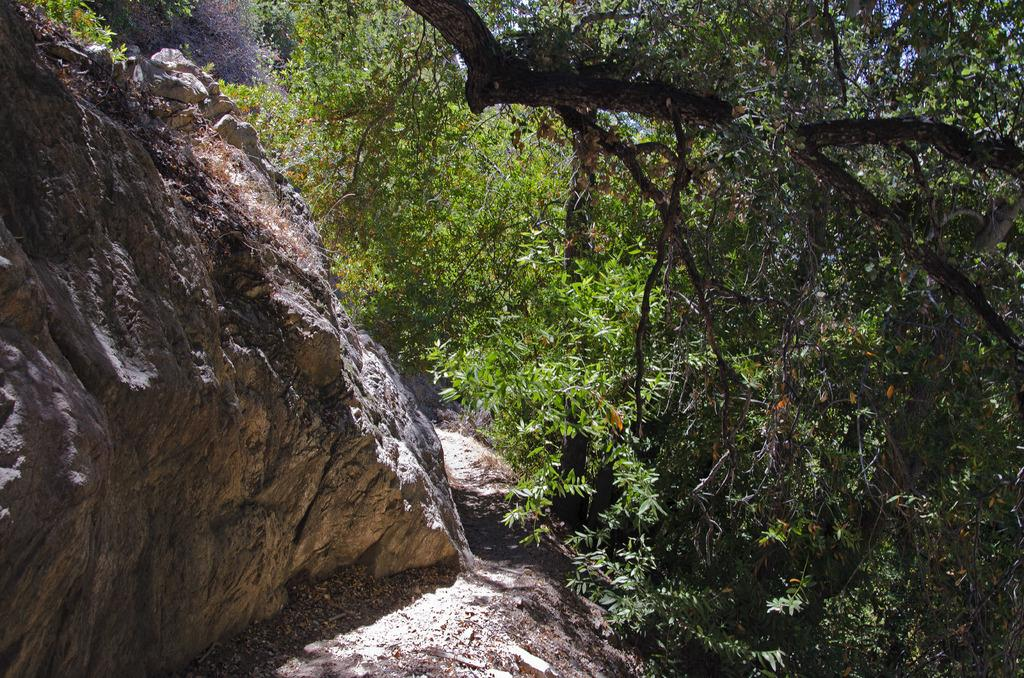Where was the image taken? The image was clicked outside. What can be seen in the middle of the image? There are trees in the middle of the image. What type of natural formation is on the left side of the image? There are rocks on the left side of the image. What time of day is it in the image, and can you see a stream? The time of day is not mentioned in the image, and there is no stream visible. Is anyone wearing a mask in the image? There are no people present in the image, so no one is wearing a mask. 